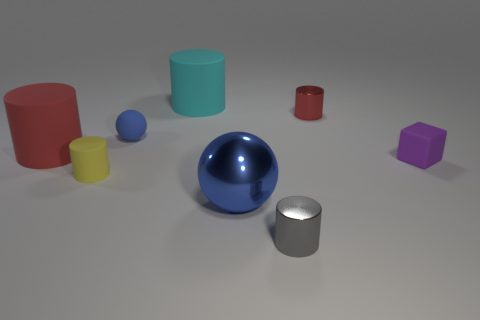Subtract 2 cylinders. How many cylinders are left? 3 Subtract all brown cylinders. Subtract all brown balls. How many cylinders are left? 5 Add 2 tiny gray shiny cylinders. How many objects exist? 10 Subtract all spheres. How many objects are left? 6 Subtract all big blue rubber cylinders. Subtract all purple rubber objects. How many objects are left? 7 Add 5 small rubber things. How many small rubber things are left? 8 Add 6 small brown matte things. How many small brown matte things exist? 6 Subtract 0 yellow cubes. How many objects are left? 8 